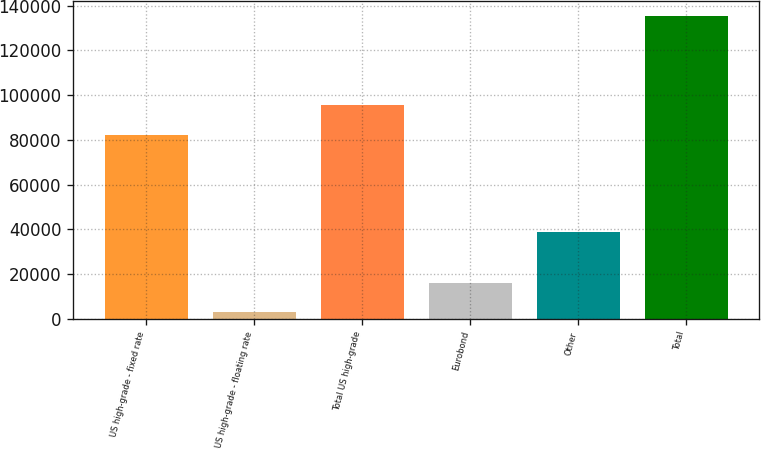Convert chart to OTSL. <chart><loc_0><loc_0><loc_500><loc_500><bar_chart><fcel>US high-grade - fixed rate<fcel>US high-grade - floating rate<fcel>Total US high-grade<fcel>Eurobond<fcel>Other<fcel>Total<nl><fcel>82267<fcel>2938<fcel>95491.1<fcel>16162.1<fcel>38661<fcel>135179<nl></chart> 